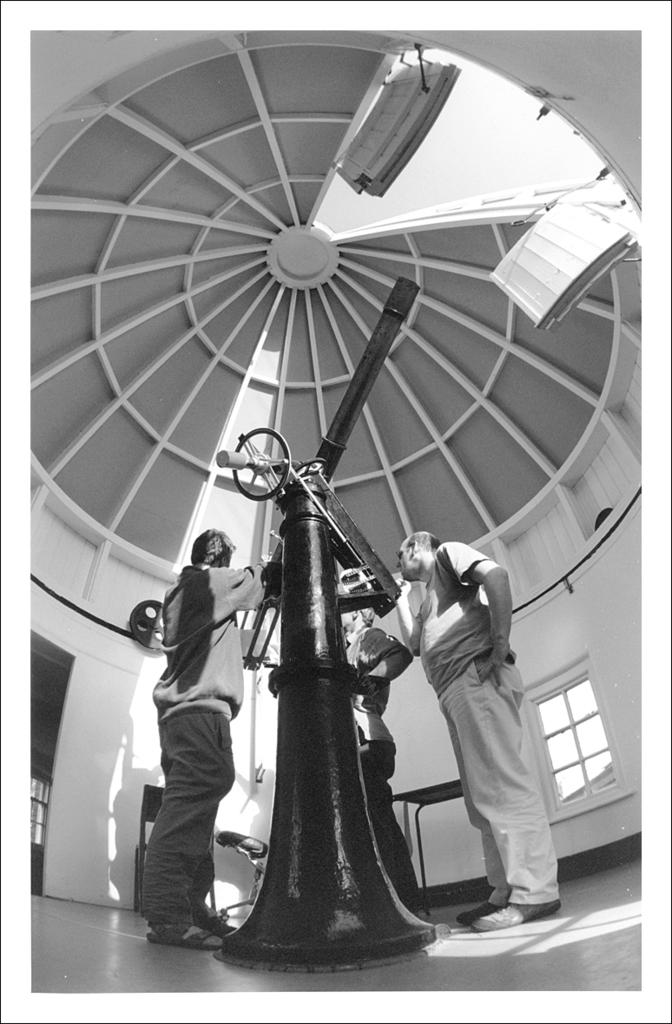What is located in the center of the image? There are people and a windmill in the center of the image. What type of structure is present in the image? There is a windmill in the center of the image. What can be seen at the top side of the image? There is an open roof area at the top side of the image. How many grains of sand can be seen on the windmill in the image? There is no sand present in the image, so it is not possible to determine the number of grains of sand on the windmill. What type of town is depicted in the image? The image does not depict a town; it features a windmill and people in an open area. 